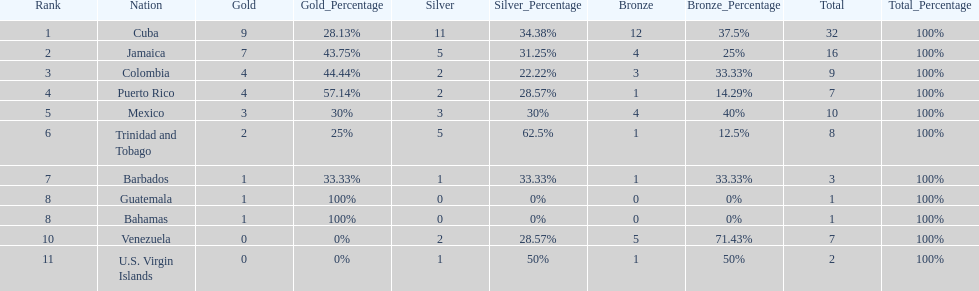Which team had four gold models and one bronze medal? Puerto Rico. Write the full table. {'header': ['Rank', 'Nation', 'Gold', 'Gold_Percentage', 'Silver', 'Silver_Percentage', 'Bronze', 'Bronze_Percentage', 'Total', 'Total_Percentage'], 'rows': [['1', 'Cuba', '9', '28.13%', '11', '34.38%', '12', '37.5%', '32', '100%'], ['2', 'Jamaica', '7', '43.75%', '5', '31.25%', '4', '25%', '16', '100%'], ['3', 'Colombia', '4', '44.44%', '2', '22.22%', '3', '33.33%', '9', '100%'], ['4', 'Puerto Rico', '4', '57.14%', '2', '28.57%', '1', '14.29%', '7', '100%'], ['5', 'Mexico', '3', '30%', '3', '30%', '4', '40%', '10', '100%'], ['6', 'Trinidad and Tobago', '2', '25%', '5', '62.5%', '1', '12.5%', '8', '100%'], ['7', 'Barbados', '1', '33.33%', '1', '33.33%', '1', '33.33%', '3', '100%'], ['8', 'Guatemala', '1', '100%', '0', '0%', '0', '0%', '1', '100%'], ['8', 'Bahamas', '1', '100%', '0', '0%', '0', '0%', '1', '100%'], ['10', 'Venezuela', '0', '0%', '2', '28.57%', '5', '71.43%', '7', '100%'], ['11', 'U.S. Virgin Islands', '0', '0%', '1', '50%', '1', '50%', '2', '100%']]} 